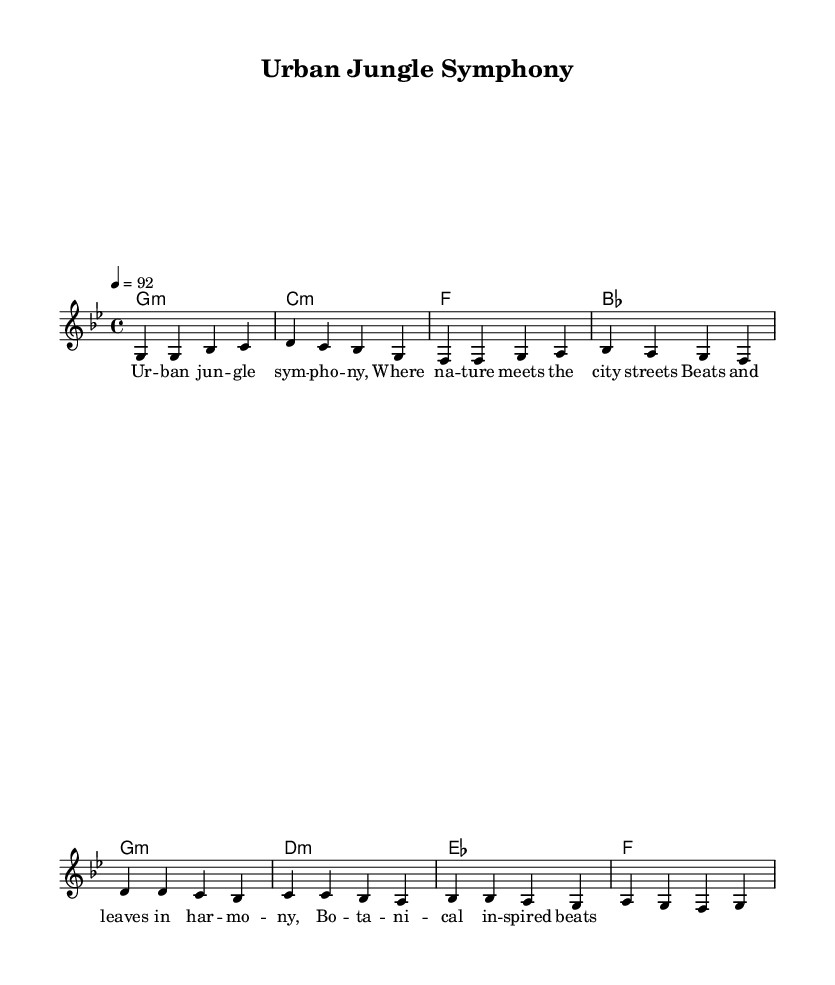What is the key signature of this music? The key signature at the beginning of the score indicates G minor, which has two flats. You can identify this by looking at the key signature notation following the clef symbol.
Answer: G minor What is the time signature of this music? The time signature displayed at the beginning of the score is 4/4, meaning there are four beats per measure and a quarter note gets one beat. This can be seen near the beginning of the score.
Answer: 4/4 What is the tempo marking indicated in this music? The tempo marking shown is "4 = 92," which tells us that there should be 92 beats per minute, and the "4" indicates the quarter note. This is located at the start of the score.
Answer: 92 How many measures does the melody have? By counting the measures in the melody part, there are eight measures total, which is derived from the phrasing and separation of notes in the score.
Answer: 8 What are the chords used in the harmony section? The chords listed in the harmony section are G minor, C minor, F, and B flat. By examining the chord mode section, you can see the progression laid out.
Answer: G minor, C minor, F, B flat What is the lyrical theme of this Hip Hop piece? The lyrics reflect an appreciation of nature within an urban environment, highlighting a blend between the city life and botanical elements. This can be inferred from the lyrics accompanying the melody.
Answer: Urban nature appreciation What aspect makes this music Hip Hop as opposed to other genres? The incorporation of street life themes and urban elements, combined with rhythmic beats characteristic of Hip Hop, sets it apart. You can recognize this through the lyrical content as well as the structure and style of the beats.
Answer: Street life and nature blend 